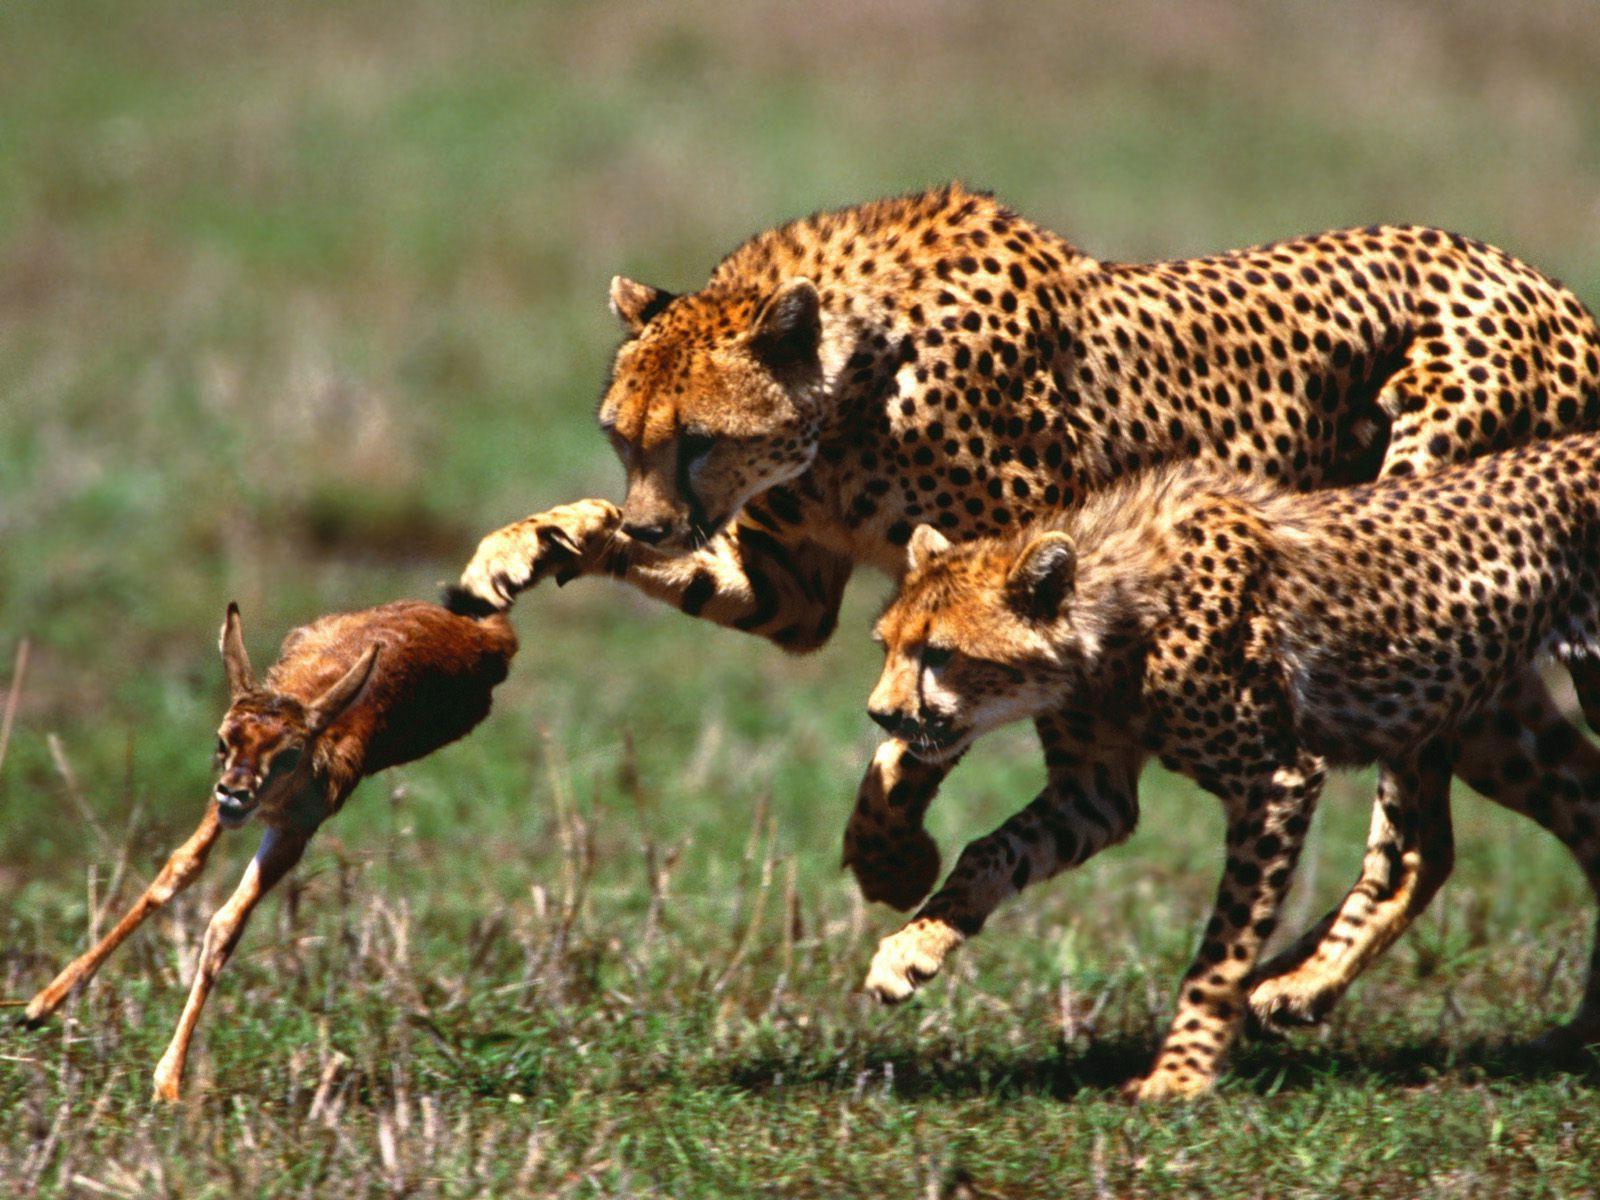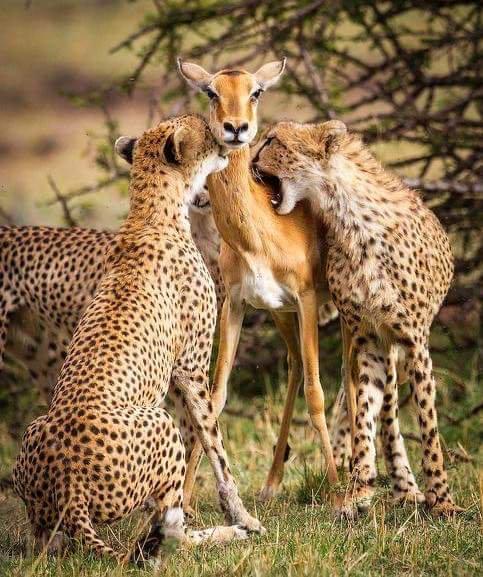The first image is the image on the left, the second image is the image on the right. Examine the images to the left and right. Is the description "One image includes an adult cheetah with its tongue out and no prey present, and the other image shows a gazelle preyed on by at least one cheetah." accurate? Answer yes or no. No. The first image is the image on the left, the second image is the image on the right. Assess this claim about the two images: "In one of the images, there is at least one cheetah cub.". Correct or not? Answer yes or no. No. 